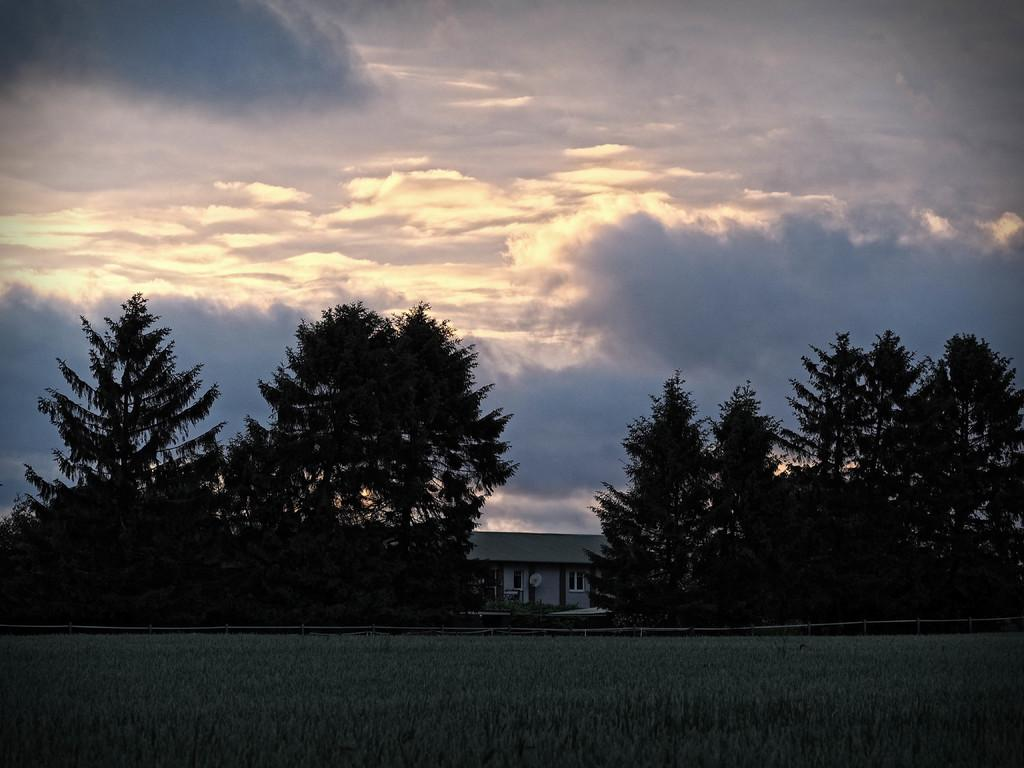What type of vegetation can be seen in the image? There is grass and trees in the image. What type of structure is visible in the image? There is a house in the image. What is visible in the background of the image? The sky is visible in the image, and there are clouds present. Can you describe the lighting in the image? The image appears to be slightly dark. Where is the faucet located in the image? There is no faucet present in the image. What type of activity is happening during the recess in the image? There is no recess or any indication of an activity taking place in the image. 